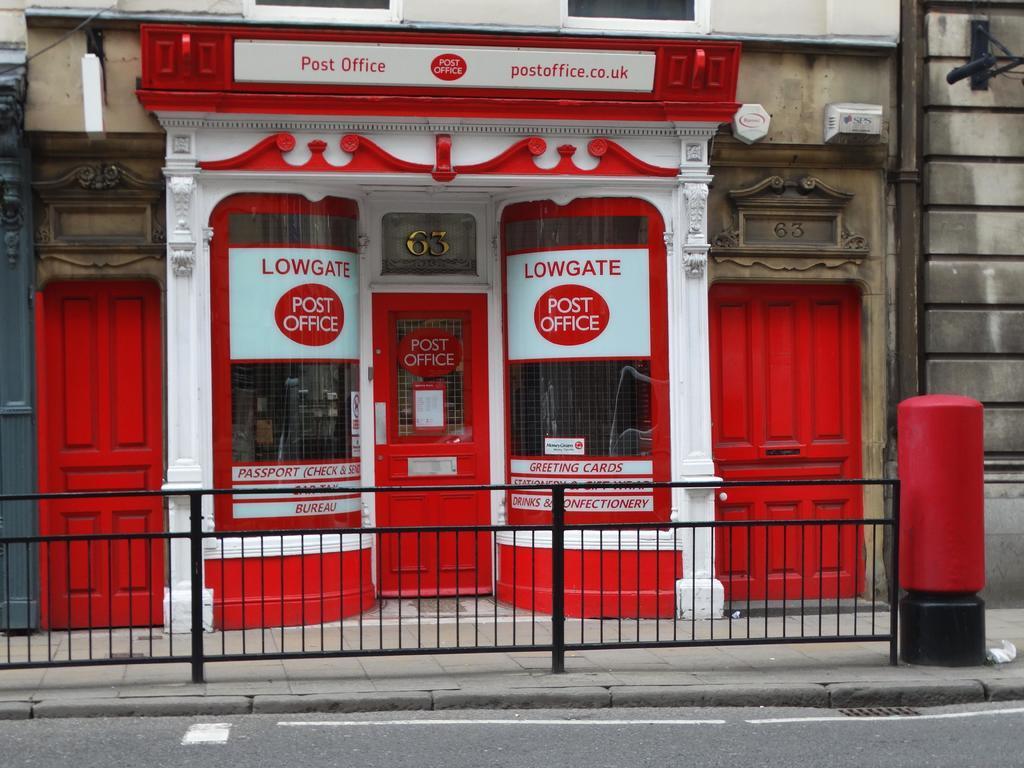Please provide a concise description of this image. In this image I can see a post box, background I can see two doors in red color, a building in cream color and I can also see the railing. 